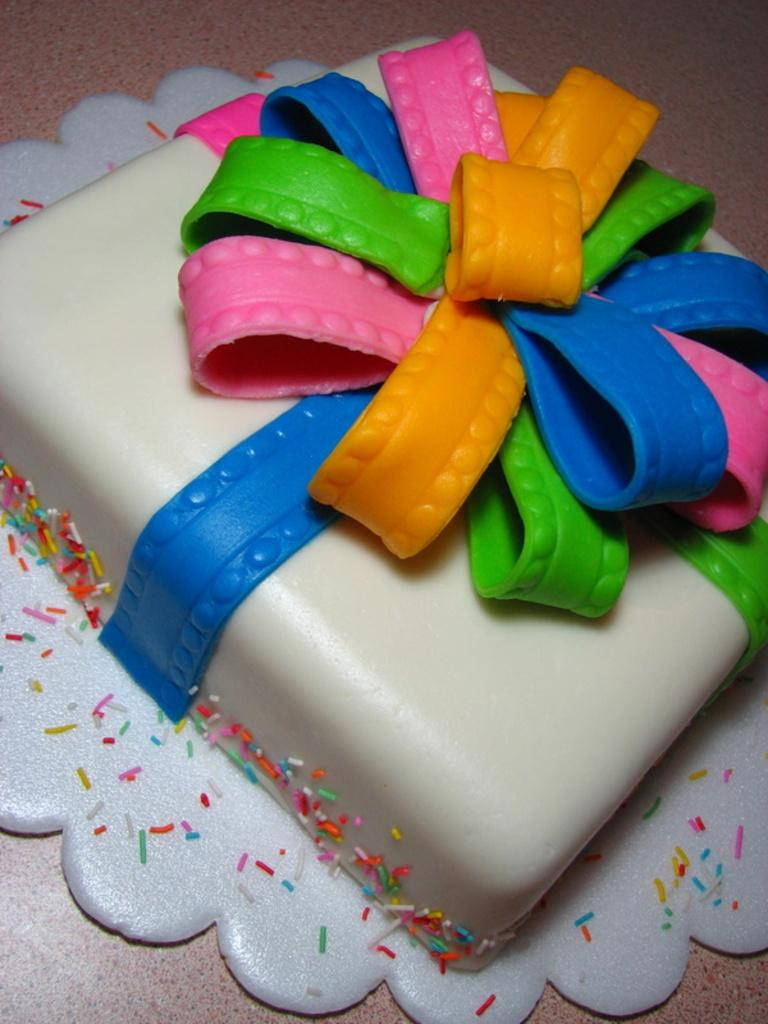What is the main subject of the image? There is a cake in the image. What colors can be seen on the cake? The cake has white, blue, yellow, pink, and green colors. What is the color of the surface on which the cake is placed? The cake is on a brown surface. What type of disease is depicted on the cake in the image? There is no disease depicted on the cake in the image. The cake features various colors, but no diseases are present. 